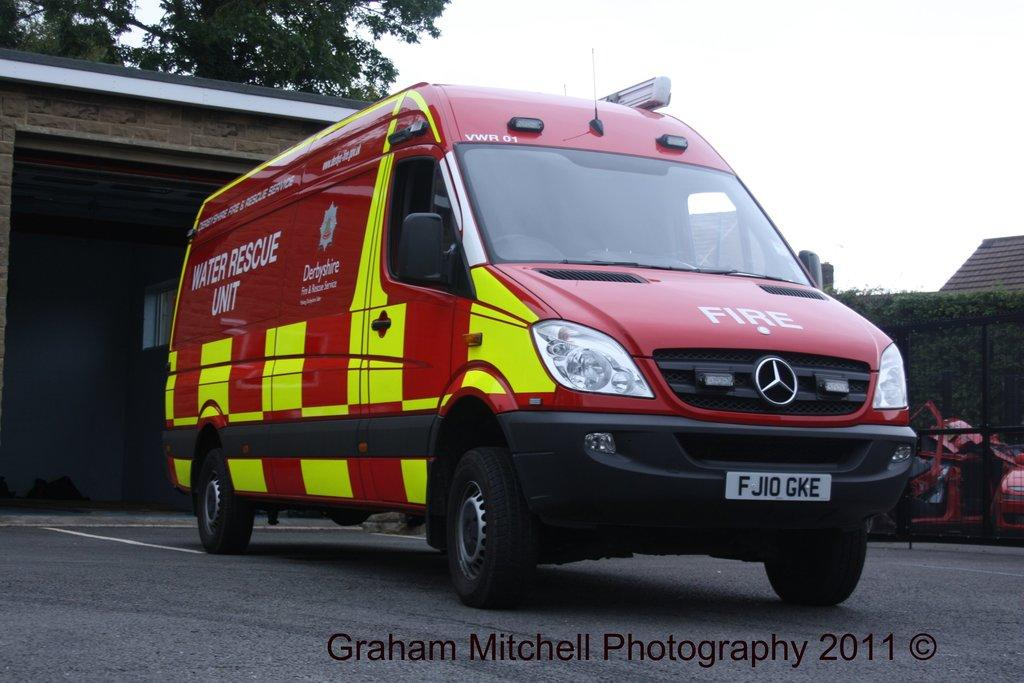<image>
Summarize the visual content of the image. a car that has the word fire on the front 